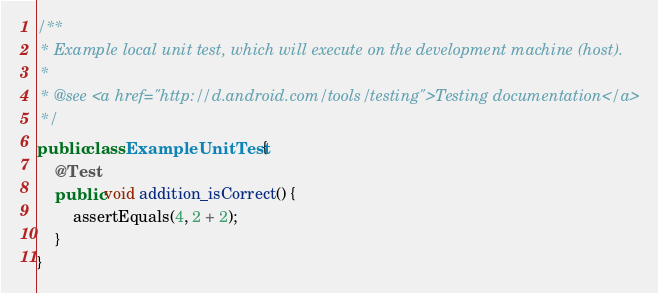<code> <loc_0><loc_0><loc_500><loc_500><_Java_>/**
 * Example local unit test, which will execute on the development machine (host).
 *
 * @see <a href="http://d.android.com/tools/testing">Testing documentation</a>
 */
public class ExampleUnitTest {
    @Test
    public void addition_isCorrect() {
        assertEquals(4, 2 + 2);
    }
}</code> 